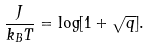<formula> <loc_0><loc_0><loc_500><loc_500>\frac { J } { k _ { B } T } = \log [ 1 + \sqrt { q } ] .</formula> 